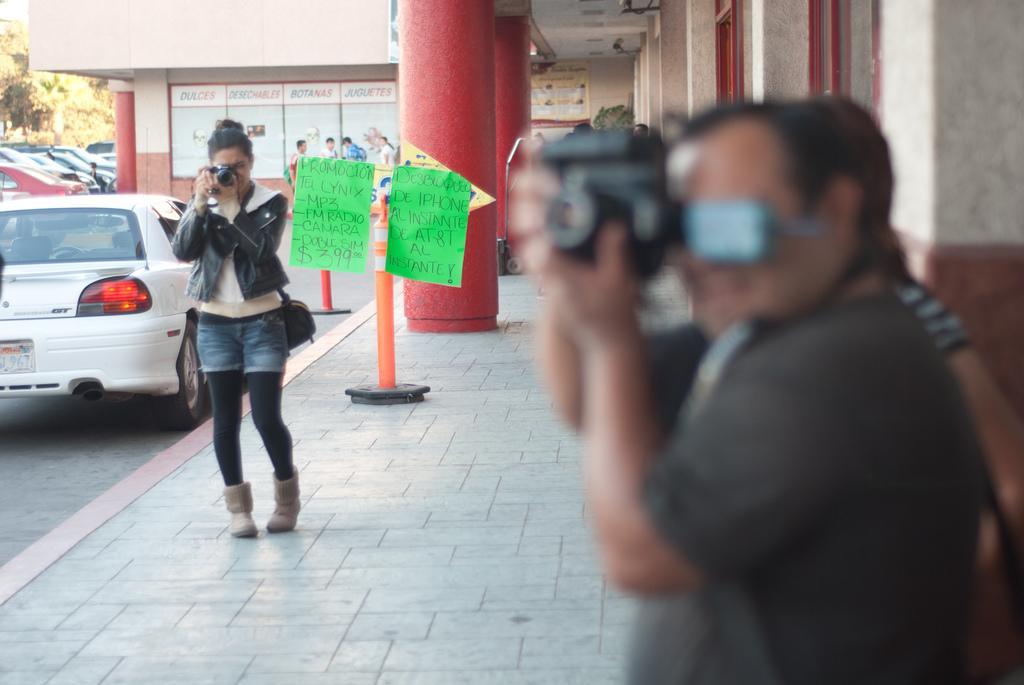Could you give a brief overview of what you see in this image? In this image we can see a few people, two of them are taking pictures using cameras, there are posters and text on the wall, there are poles, posters with some text on it, there are trees, vehicles, and a house. 